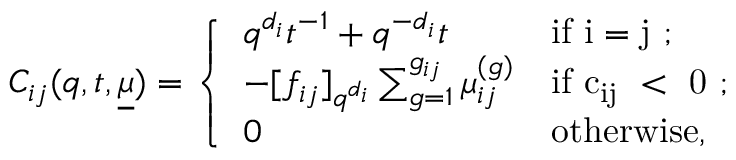<formula> <loc_0><loc_0><loc_500><loc_500>C _ { i j } ( q , t , \underline { \mu } ) = \left \{ \begin{array} { l l } { q ^ { d _ { i } } t ^ { - 1 } + q ^ { - d _ { i } } t } & { i f i = j ; } \\ { - [ f _ { i j } ] _ { q ^ { d _ { i } } } \sum _ { g = 1 } ^ { g _ { i j } } \mu _ { i j } ^ { ( g ) } } & { i f c _ { i j } < 0 ; } \\ { 0 } & { o t h e r w i s e , } \end{array}</formula> 